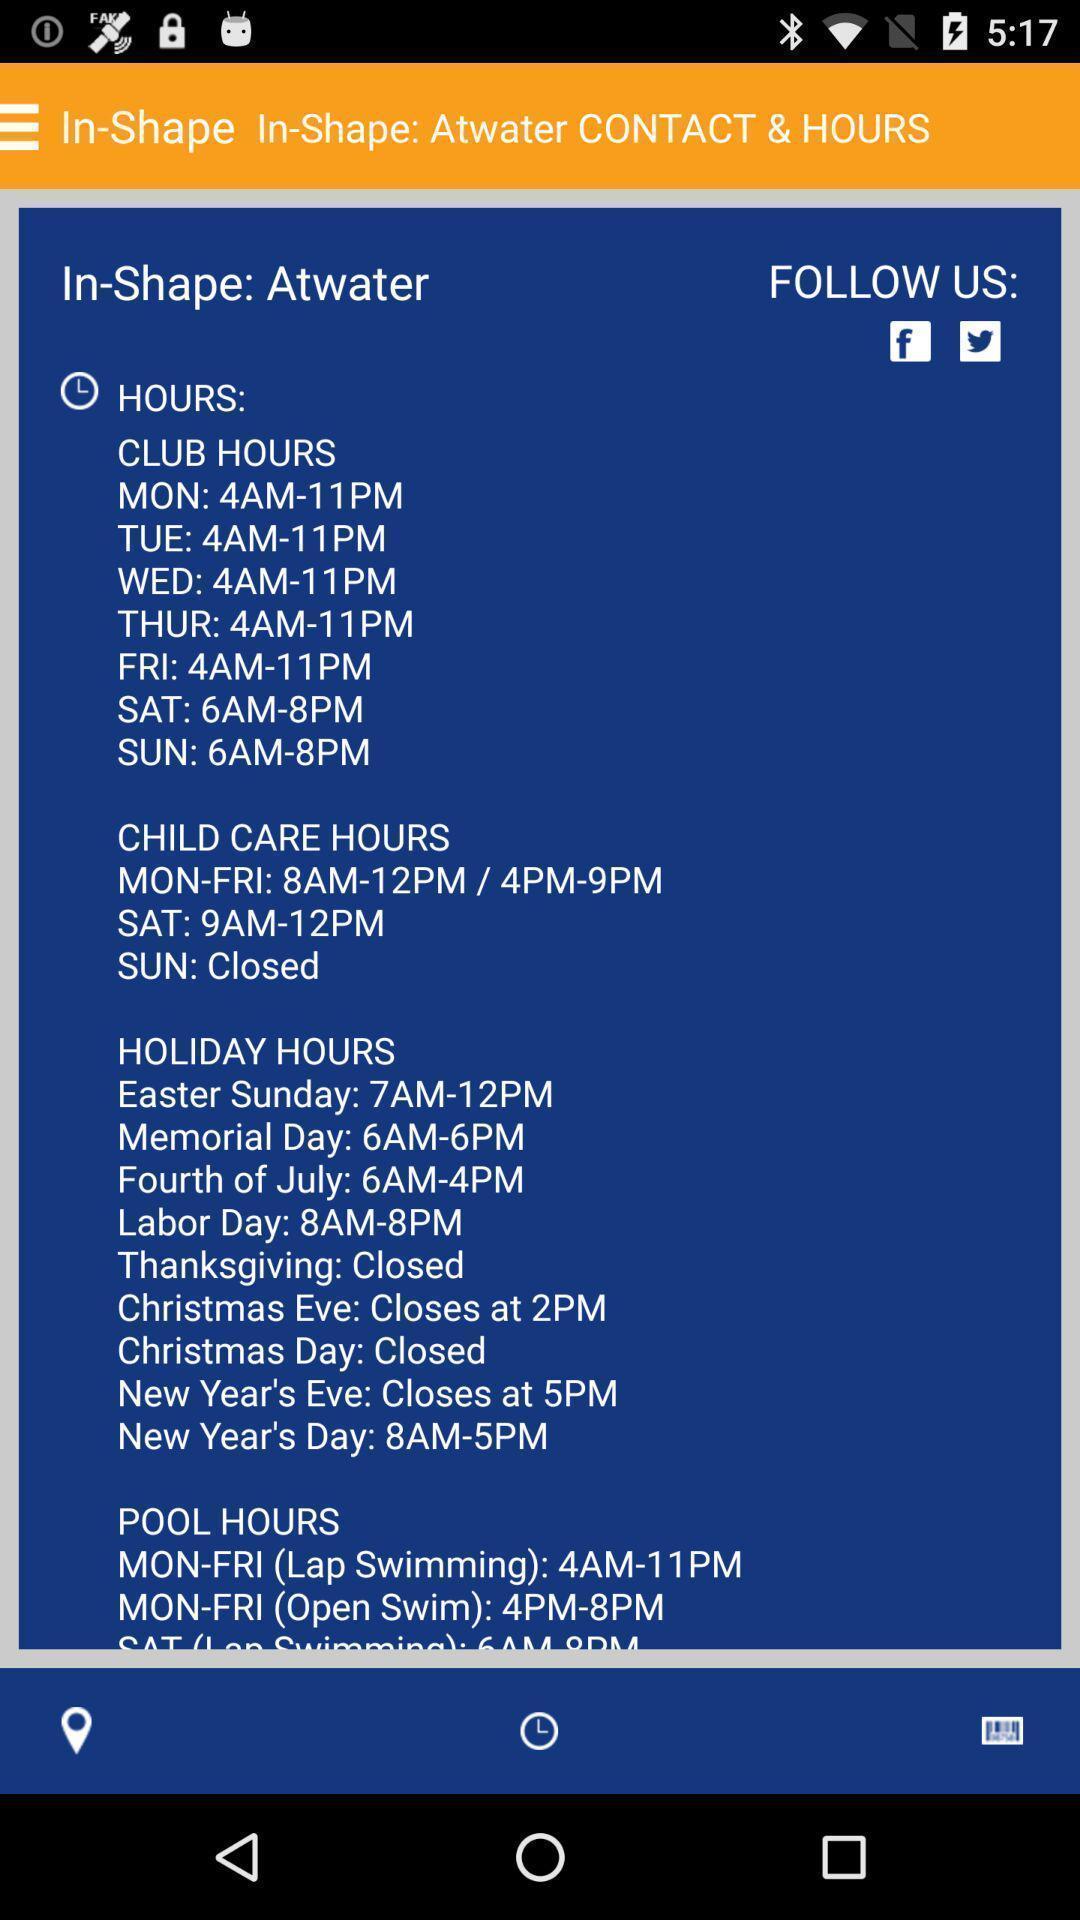Explain what's happening in this screen capture. Page displaying visiting hours. 